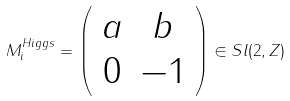Convert formula to latex. <formula><loc_0><loc_0><loc_500><loc_500>M _ { i } ^ { H i g g s } = \left ( \begin{array} { c c } { a } & { b } \\ { 0 } & { - 1 } \end{array} \right ) \in S l ( 2 , Z )</formula> 